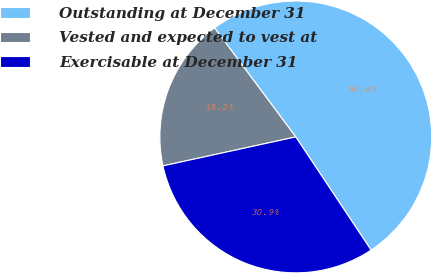Convert chart to OTSL. <chart><loc_0><loc_0><loc_500><loc_500><pie_chart><fcel>Outstanding at December 31<fcel>Vested and expected to vest at<fcel>Exercisable at December 31<nl><fcel>50.84%<fcel>18.23%<fcel>30.93%<nl></chart> 